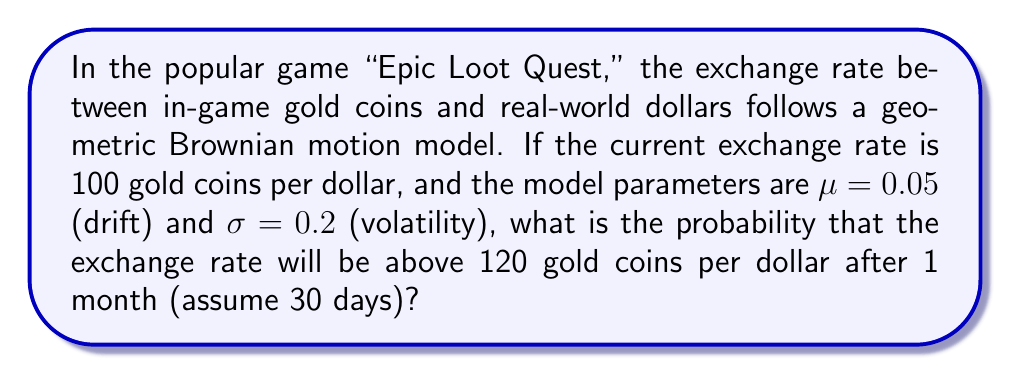Can you solve this math problem? Let's approach this step-by-step:

1) The geometric Brownian motion model for asset prices is given by:

   $$S_t = S_0 \exp\left(\left(\mu - \frac{\sigma^2}{2}\right)t + \sigma W_t\right)$$

   where $S_t$ is the price at time $t$, $S_0$ is the initial price, $\mu$ is the drift, $\sigma$ is the volatility, and $W_t$ is a Wiener process.

2) In this case, $S_0 = 100$, $\mu = 0.05$, $\sigma = 0.2$, and $t = \frac{30}{365} \approx 0.0822$ (as we're looking at a 30-day period).

3) The log of the price follows a normal distribution:

   $$\ln(S_t) \sim N\left(\ln(S_0) + \left(\mu - \frac{\sigma^2}{2}\right)t, \sigma^2t\right)$$

4) We want to find $P(S_t > 120)$, which is equivalent to $P(\ln(S_t) > \ln(120))$.

5) Calculate the mean and variance of $\ln(S_t)$:

   Mean: $\ln(100) + (0.05 - \frac{0.2^2}{2})0.0822 \approx 4.6046$
   Variance: $0.2^2 * 0.0822 = 0.003288$

6) Standardize the random variable:

   $$Z = \frac{\ln(120) - 4.6046}{\sqrt{0.003288}} \approx 0.7656$$

7) The probability we're looking for is $P(Z > 0.7656)$, which is equal to $1 - \Phi(0.7656)$, where $\Phi$ is the standard normal cumulative distribution function.

8) Using a standard normal table or calculator, we find:

   $1 - \Phi(0.7656) \approx 0.2220$

Therefore, the probability that the exchange rate will be above 120 gold coins per dollar after 1 month is approximately 0.2220 or 22.20%.
Answer: 0.2220 